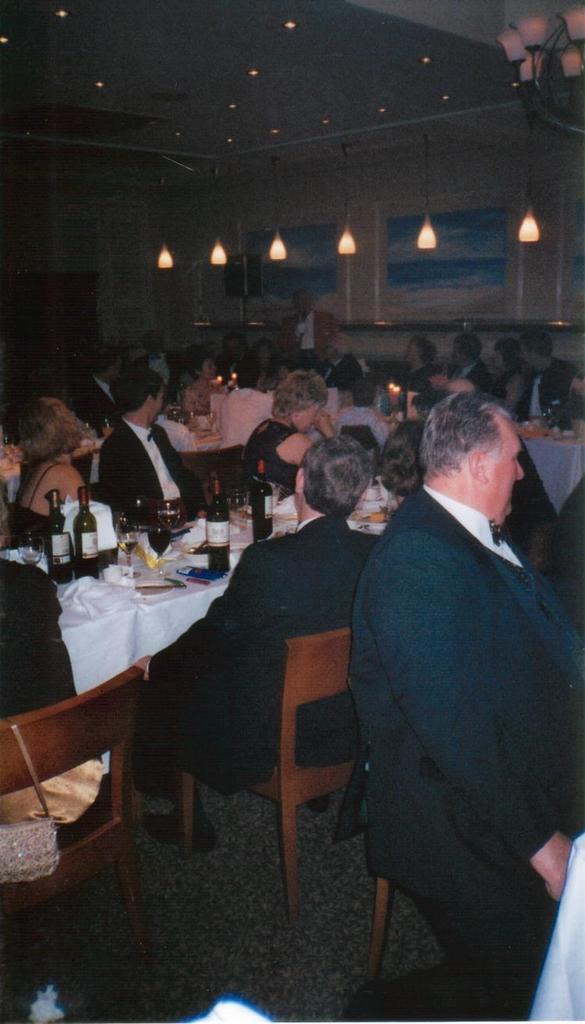In one or two sentences, can you explain what this image depicts? In this room most of the persons are sitting on chair. A poster on wall. This lights are attached to roof top. On tables there are bottles and glasses. 